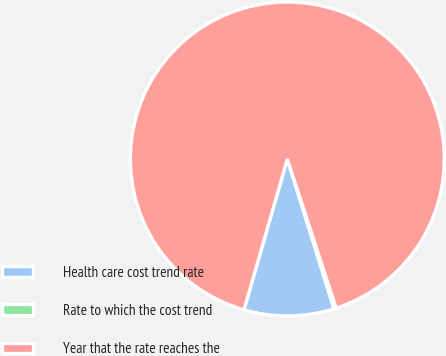Convert chart. <chart><loc_0><loc_0><loc_500><loc_500><pie_chart><fcel>Health care cost trend rate<fcel>Rate to which the cost trend<fcel>Year that the rate reaches the<nl><fcel>9.26%<fcel>0.23%<fcel>90.51%<nl></chart> 